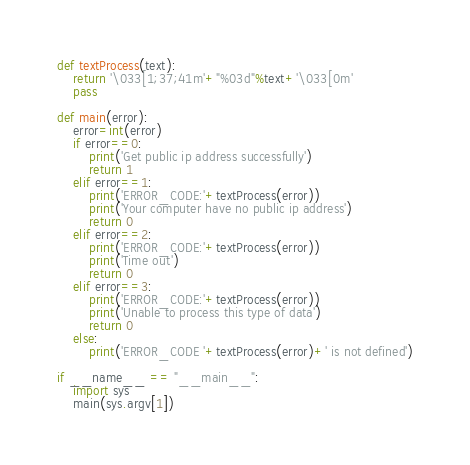<code> <loc_0><loc_0><loc_500><loc_500><_Python_>def textProcess(text):
    return '\033[1;37;41m'+"%03d"%text+'\033[0m'
    pass

def main(error):
    error=int(error)
    if error==0:
        print('Get public ip address successfully')
        return 1
    elif error==1:
        print('ERROR_CODE:'+textProcess(error))
        print('Your computer have no public ip address')
        return 0
    elif error==2:
        print('ERROR_CODE:'+textProcess(error))
        print('Time out')
        return 0
    elif error==3:
        print('ERROR_CODE:'+textProcess(error))
        print('Unable to process this type of data')
        return 0
    else:
        print('ERROR_CODE '+textProcess(error)+' is not defined')
        
if __name__ == "__main__":
    import sys
    main(sys.argv[1])</code> 